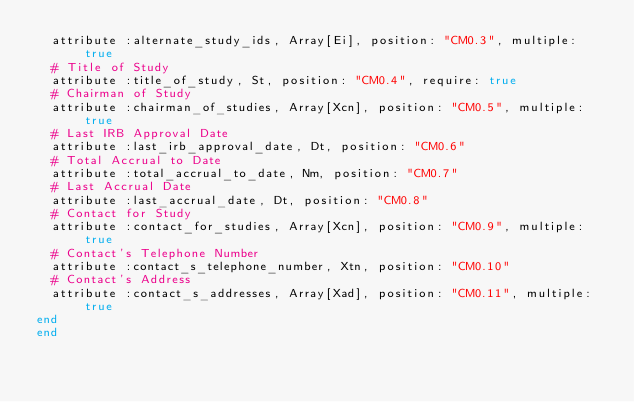Convert code to text. <code><loc_0><loc_0><loc_500><loc_500><_Ruby_>  attribute :alternate_study_ids, Array[Ei], position: "CM0.3", multiple: true
  # Title of Study
  attribute :title_of_study, St, position: "CM0.4", require: true
  # Chairman of Study
  attribute :chairman_of_studies, Array[Xcn], position: "CM0.5", multiple: true
  # Last IRB Approval Date
  attribute :last_irb_approval_date, Dt, position: "CM0.6"
  # Total Accrual to Date
  attribute :total_accrual_to_date, Nm, position: "CM0.7"
  # Last Accrual Date
  attribute :last_accrual_date, Dt, position: "CM0.8"
  # Contact for Study
  attribute :contact_for_studies, Array[Xcn], position: "CM0.9", multiple: true
  # Contact's Telephone Number
  attribute :contact_s_telephone_number, Xtn, position: "CM0.10"
  # Contact's Address
  attribute :contact_s_addresses, Array[Xad], position: "CM0.11", multiple: true
end
end</code> 